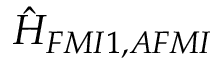Convert formula to latex. <formula><loc_0><loc_0><loc_500><loc_500>\hat { H } _ { F M I 1 , A F M I }</formula> 